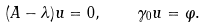Convert formula to latex. <formula><loc_0><loc_0><loc_500><loc_500>( A - \lambda ) u = 0 , \quad \gamma _ { 0 } u = \varphi .</formula> 